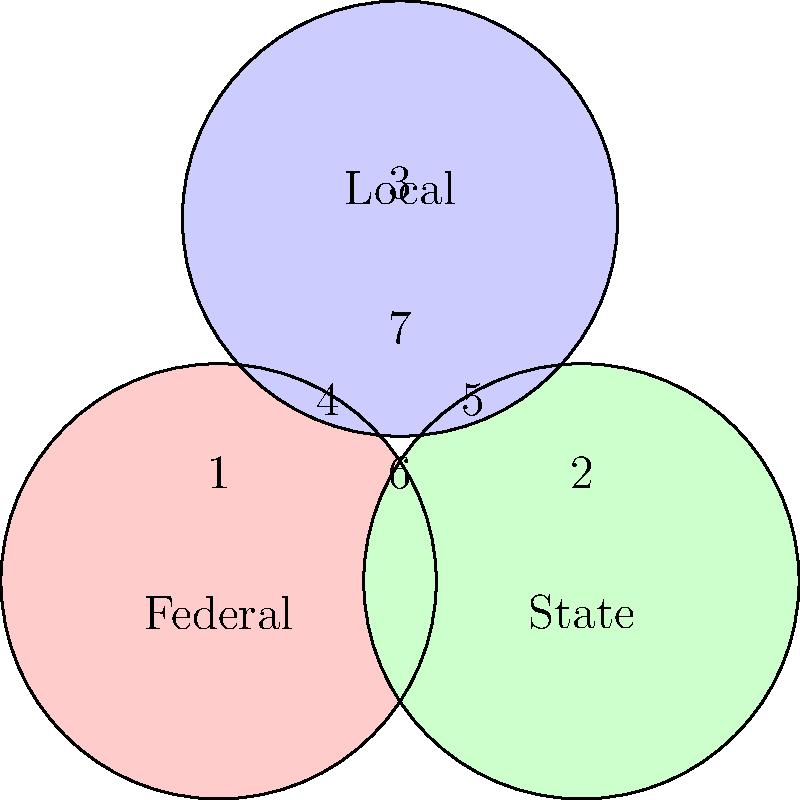In the Venn diagram representing jurisdictional overlap in sex crime prosecution, which area represents cases that fall under both federal and state jurisdiction but not local jurisdiction? To answer this question, we need to analyze the Venn diagram and understand the overlapping areas:

1. The diagram shows three circles representing Federal, State, and Local jurisdictions.
2. Each circle overlaps with the others, creating seven distinct areas labeled 1 through 7.
3. We are looking for an area that is covered by both Federal and State jurisdictions but not Local jurisdiction.
4. Area 6 is the overlap between the Federal and State circles, but it does not include the Local circle.
5. This area represents cases that can be prosecuted at both the federal and state levels but do not fall under local jurisdiction.
6. Such cases might include interstate sex trafficking or certain online sex crimes that cross state lines but don't necessarily involve local law enforcement.

Therefore, the area that represents cases falling under both federal and state jurisdiction but not local jurisdiction is area 6 in the Venn diagram.
Answer: 6 